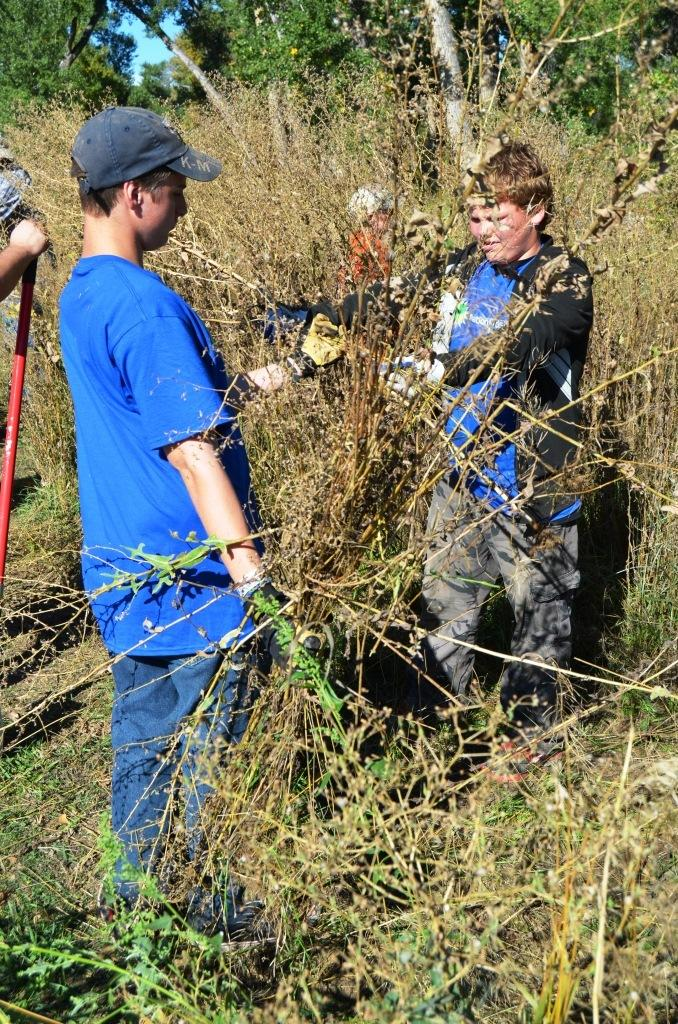What can be seen in the image? There are people standing in the image. Where are the people standing? The people are standing on the ground. What else is present in the image besides the people? There are plants and trees in the image. What is visible in the background of the image? The sky is visible in the image. What shape are the mice in the image? There are no mice present in the image. 